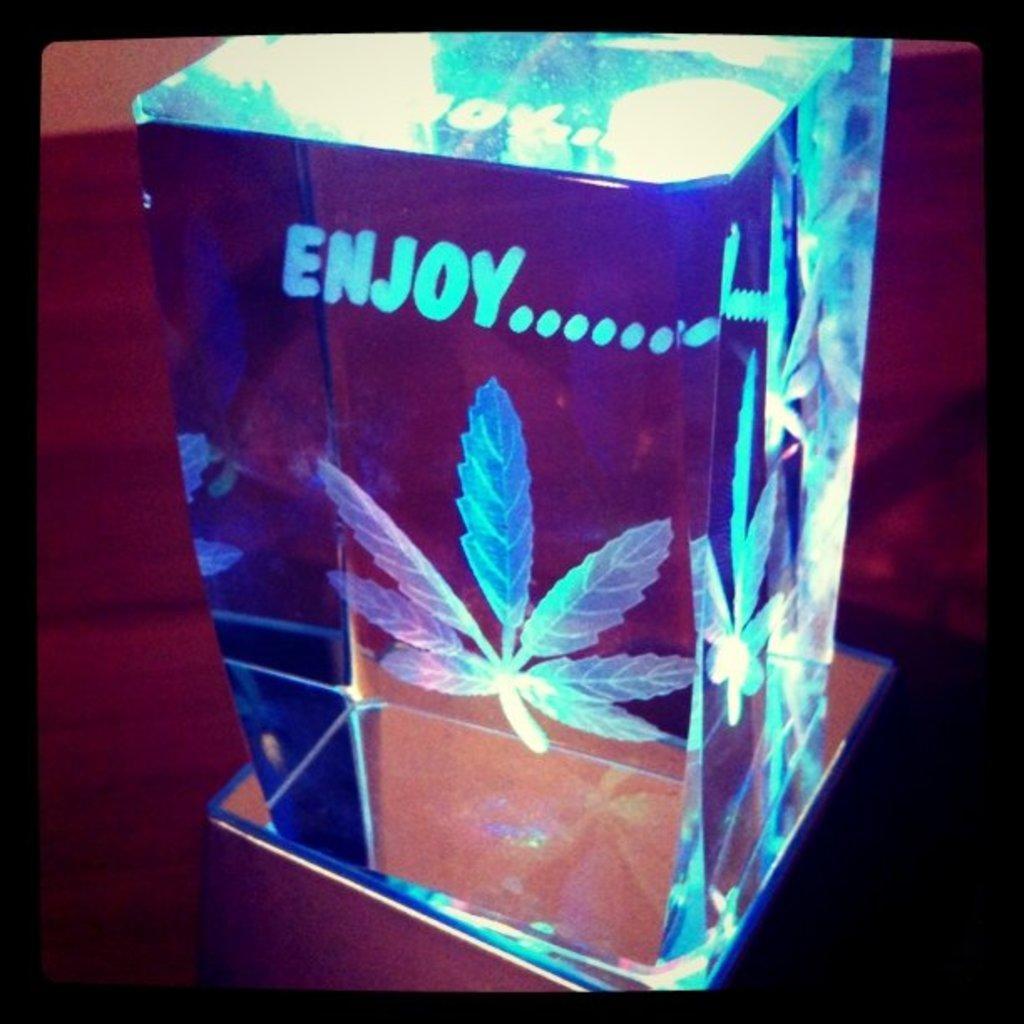How would you summarize this image in a sentence or two? In the foreground of this image, there is a cube and an art is inside is placed on the surface. 